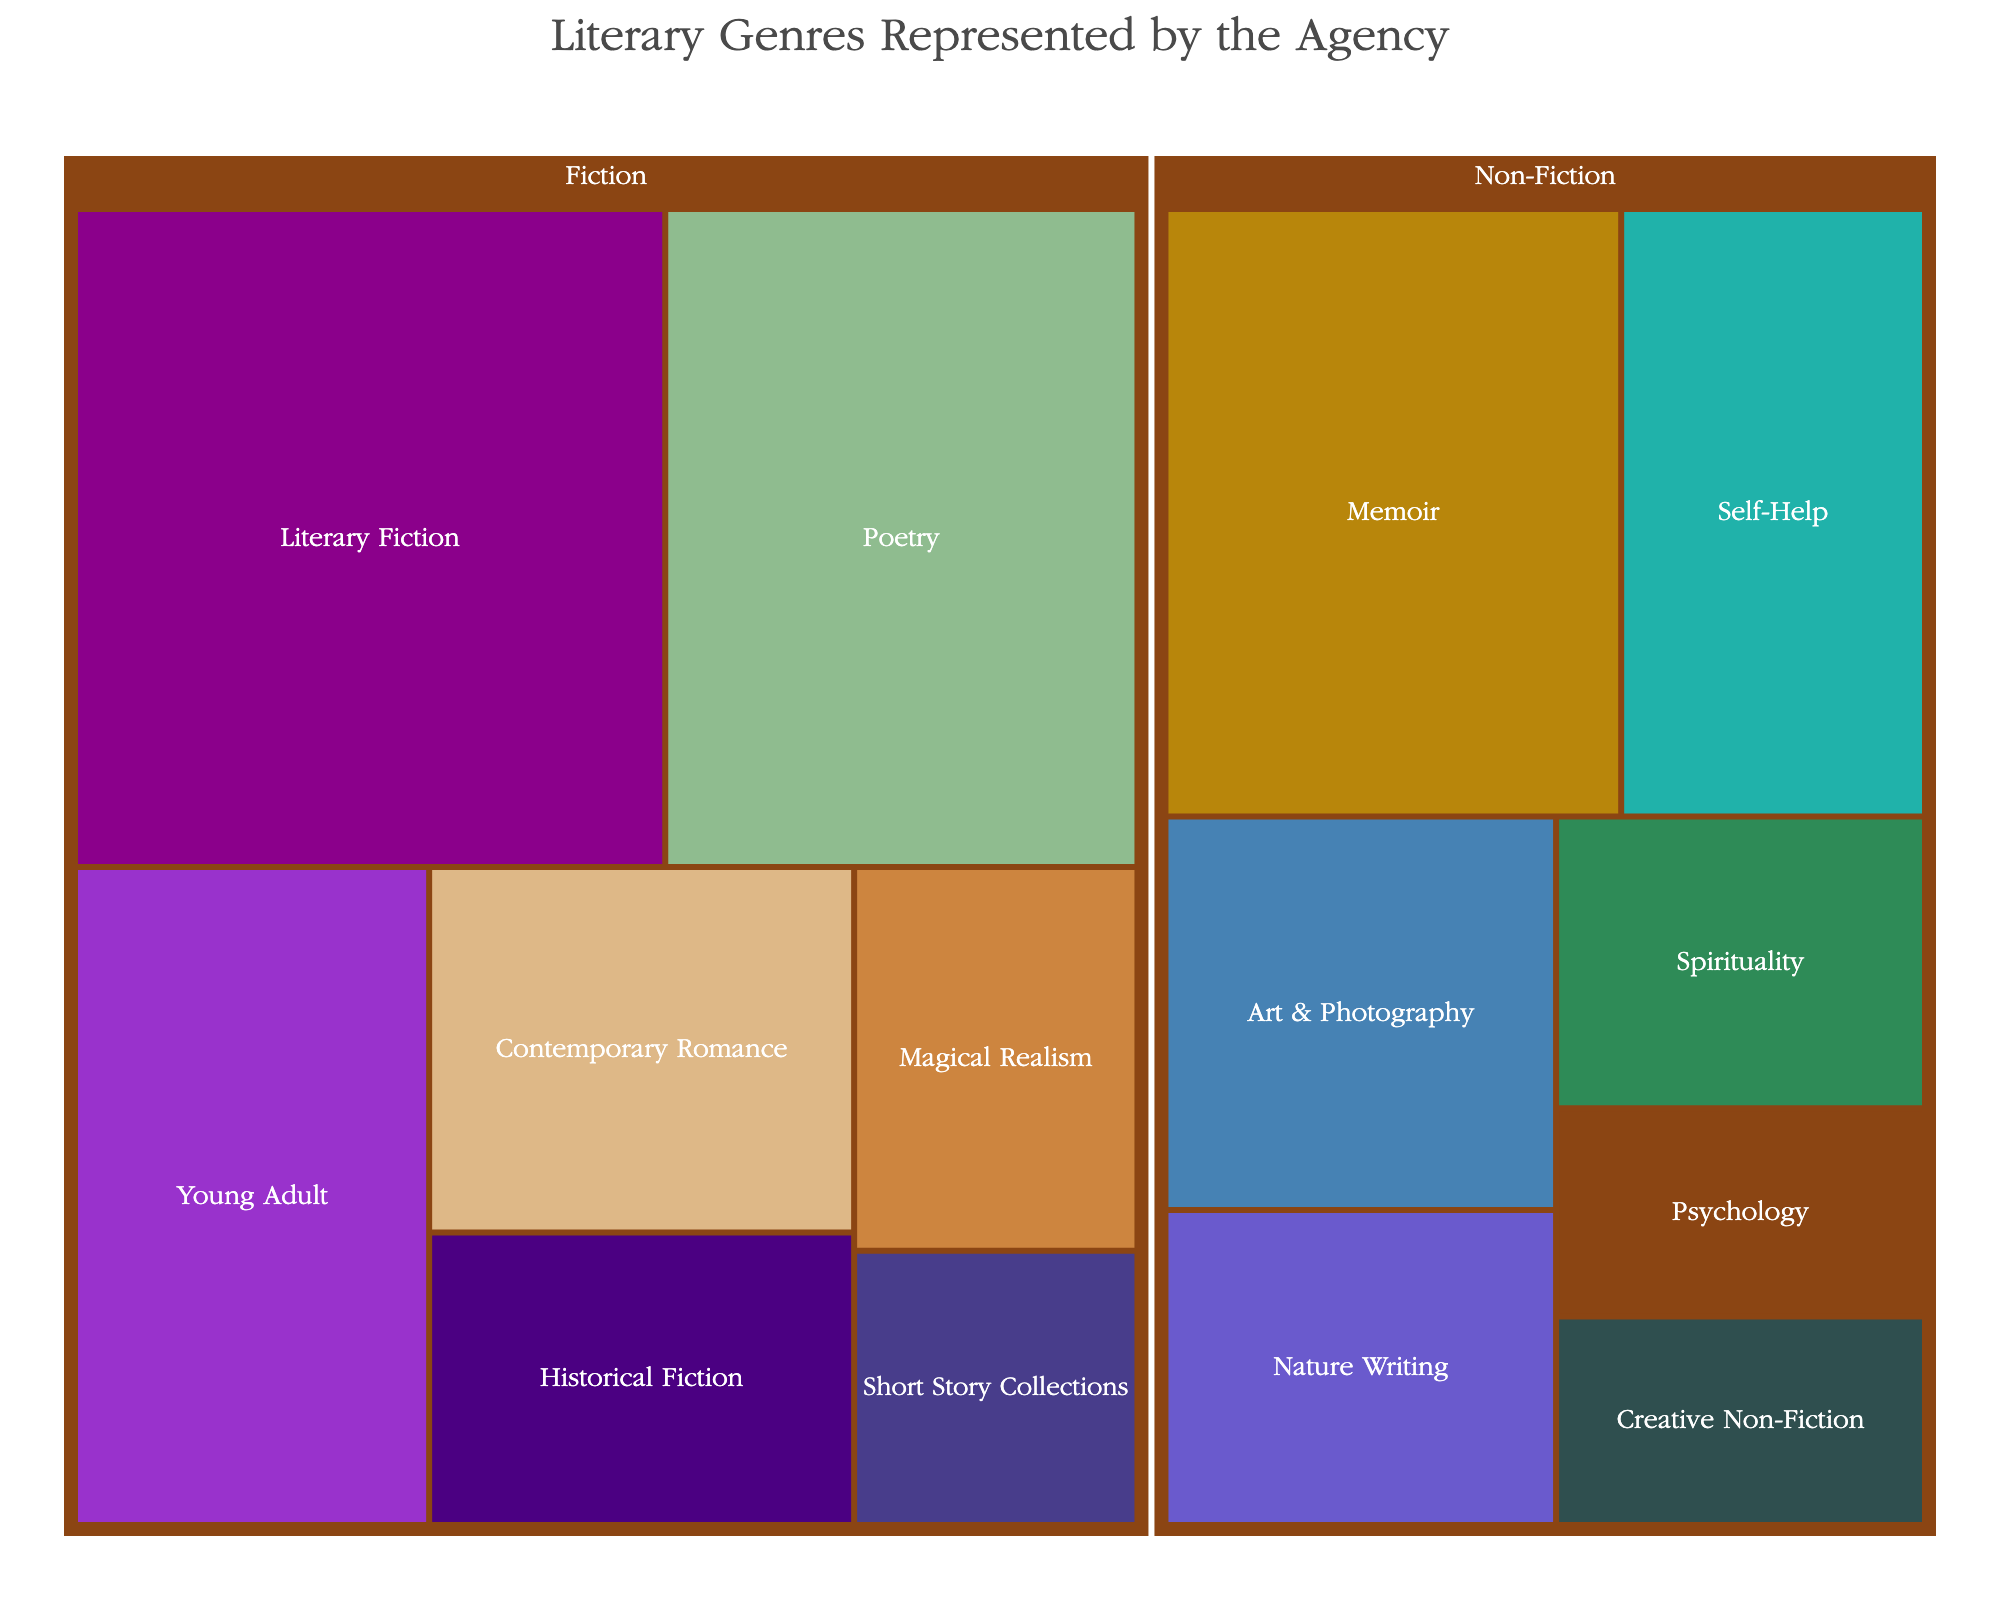what is the title of the figure? The figure's title is displayed prominently and usually provides a clear indication of what the figure represents.
Answer: Literary Genres Represented by the Agency Which Fiction genre is the most represented? By observing the size of the areas within the Fiction category, Literary Fiction has the largest area, indicating the highest representation.
Answer: Literary Fiction How many Non-Fiction sub-genres are there? The figure visually distinguishes Non-Fiction sub-genres, and one can count these areas to find the total.
Answer: 7 What is the combined representation of Fiction genres? Summing up the representation values for all Fiction sub-genres: 25 + 20 + 15 + 10 + 8 + 7 + 5.
Answer: 90 Which genre has the smallest representation? By looking at the smallest areas within both Fiction and Non-Fiction categories, the smallest goes to Creative Non-Fiction and Psychology.
Answer: Creative Non-Fiction, Psychology Compare the representation between Poetry and Memoir. Which is greater and by how much? Poetry has a representation of 20, and Memoir has 18. Subtracting Memoir's representation from Poetry's gives the difference.
Answer: Poetry by 2 What percentage of the total representation does Young Adult constitute? Divide Young Adult's representation (15) by the total sum (171) and multiply by 100 to get the percentage.
Answer: 8.77% Which category has a larger total representation, Fiction or Non-Fiction? Sum the representation values of each category and compare: Fiction (90), Non-Fiction (65).
Answer: Fiction What is the average representation per genre in the Non-Fiction category? Sum Non-Fiction's representation values (18 + 12 + 10 + 8 + 7 + 5 + 5) and divide by the number of genres (7).
Answer: 9.29 If the agency wants to equally represent Fiction and Non-Fiction categories, how many more Non-Fiction works need to be acquired? The difference between Fiction (90) and Non-Fiction (65) needs to be covered by adding more Non-Fiction works.
Answer: 25 